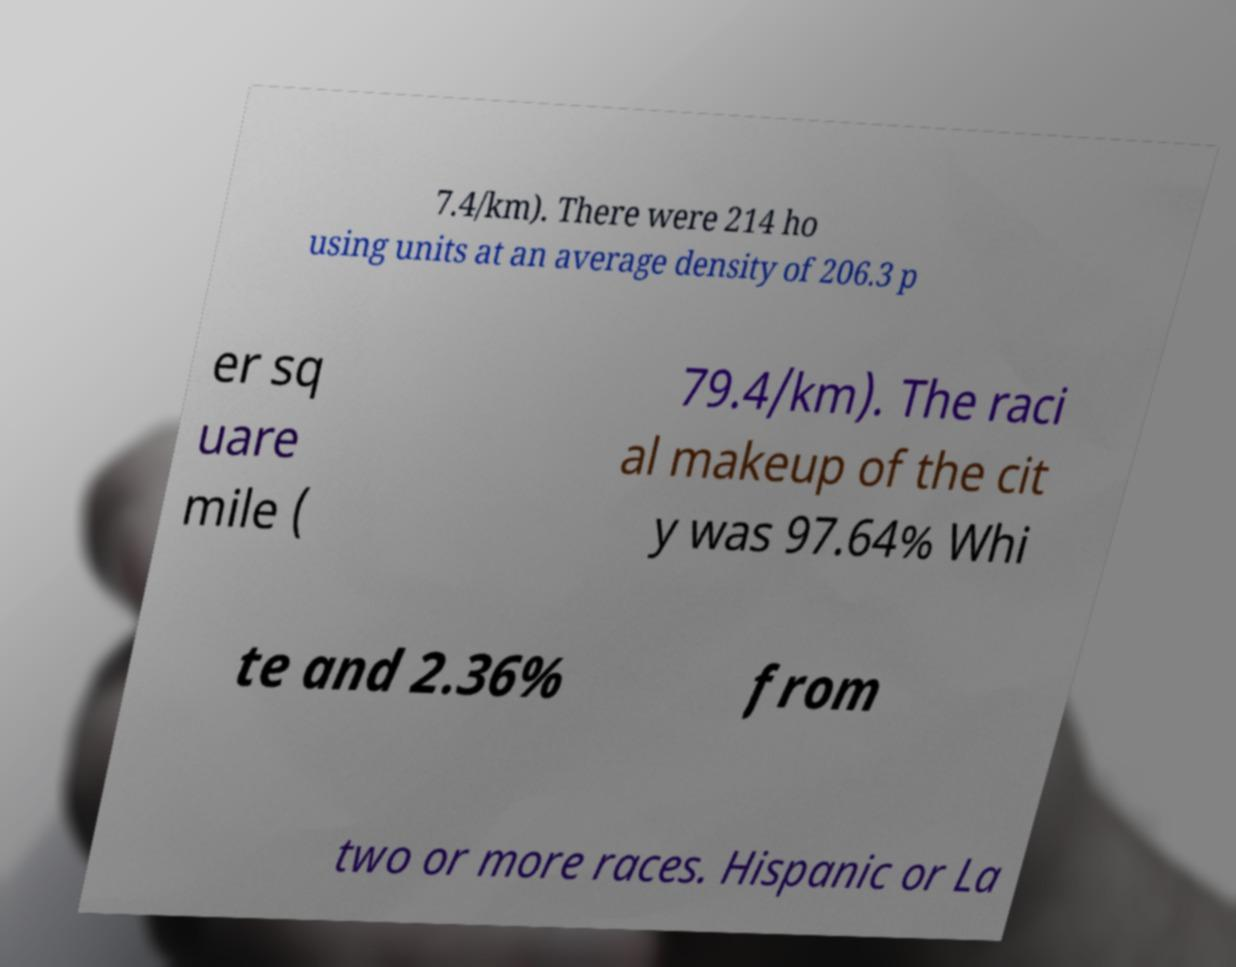Please read and relay the text visible in this image. What does it say? 7.4/km). There were 214 ho using units at an average density of 206.3 p er sq uare mile ( 79.4/km). The raci al makeup of the cit y was 97.64% Whi te and 2.36% from two or more races. Hispanic or La 